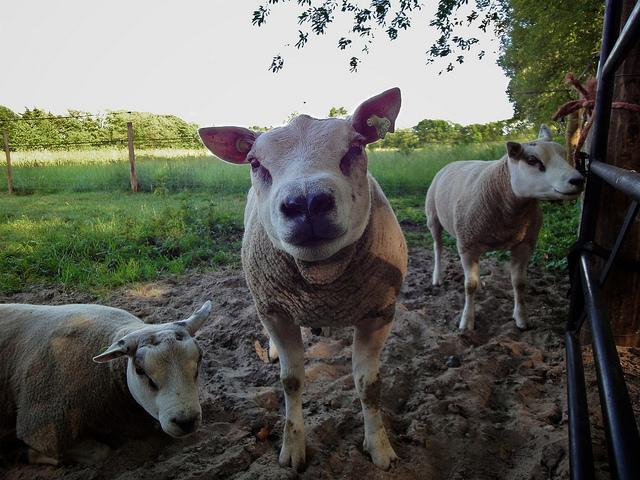Which indoor domestic animal does the center sheep resemble? Please explain your reasoning. bull terrier. The sheep resembles a dog called the bull terrier. 